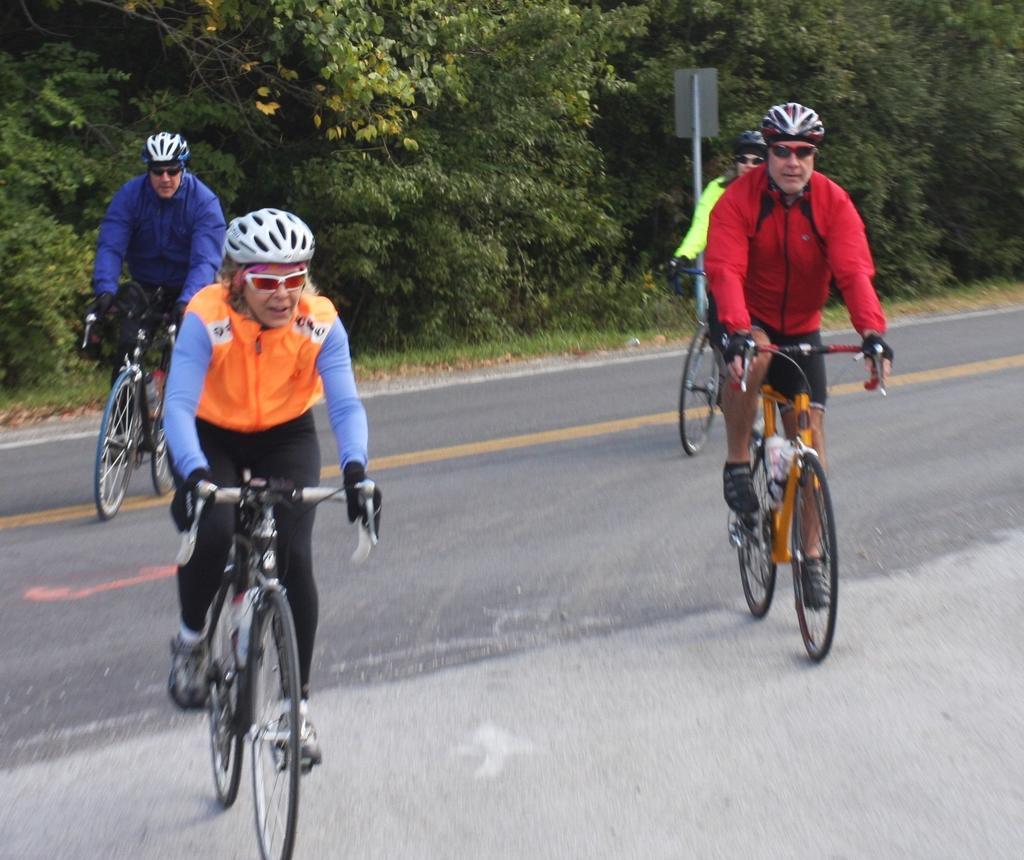In one or two sentences, can you explain what this image depicts? This is a picture on the road where four people riding their bicycles who are wearing spectacles and helmets. 